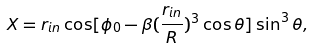<formula> <loc_0><loc_0><loc_500><loc_500>X = r _ { i n } \cos [ \phi _ { 0 } - \beta ( \frac { r _ { i n } } { R } ) ^ { 3 } \cos \theta ] \sin ^ { 3 } \theta ,</formula> 